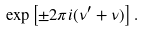Convert formula to latex. <formula><loc_0><loc_0><loc_500><loc_500>\exp \left [ \pm 2 \pi i ( \nu ^ { \prime } + \nu ) \right ] .</formula> 